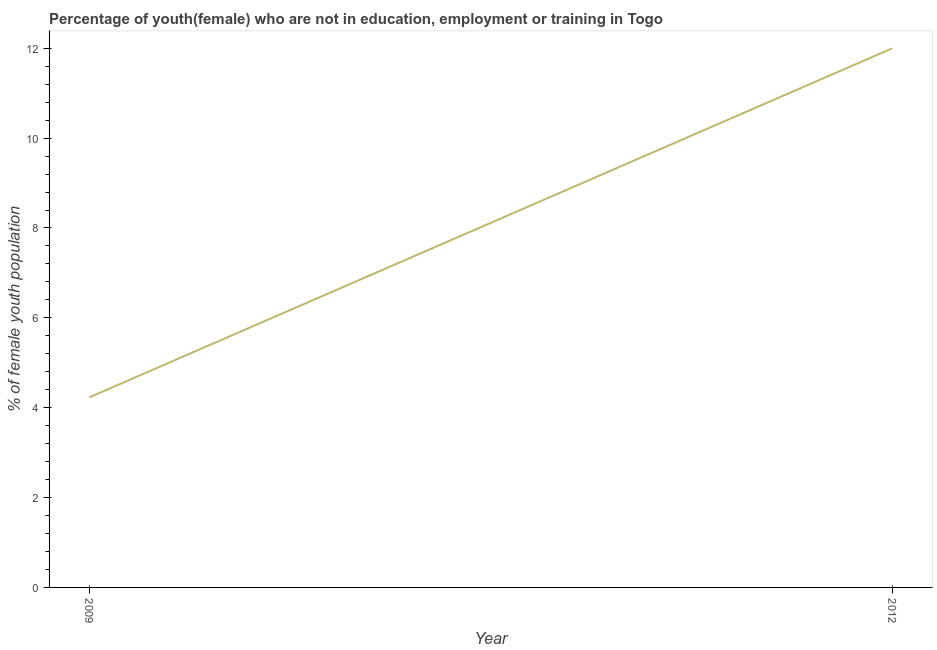Across all years, what is the minimum unemployed female youth population?
Ensure brevity in your answer.  4.23. In which year was the unemployed female youth population minimum?
Provide a short and direct response. 2009. What is the sum of the unemployed female youth population?
Your answer should be very brief. 16.23. What is the difference between the unemployed female youth population in 2009 and 2012?
Offer a terse response. -7.77. What is the average unemployed female youth population per year?
Give a very brief answer. 8.12. What is the median unemployed female youth population?
Make the answer very short. 8.12. In how many years, is the unemployed female youth population greater than 0.8 %?
Your answer should be very brief. 2. What is the ratio of the unemployed female youth population in 2009 to that in 2012?
Provide a short and direct response. 0.35. In how many years, is the unemployed female youth population greater than the average unemployed female youth population taken over all years?
Offer a very short reply. 1. How many years are there in the graph?
Your answer should be very brief. 2. What is the difference between two consecutive major ticks on the Y-axis?
Provide a succinct answer. 2. Does the graph contain any zero values?
Ensure brevity in your answer.  No. Does the graph contain grids?
Keep it short and to the point. No. What is the title of the graph?
Provide a short and direct response. Percentage of youth(female) who are not in education, employment or training in Togo. What is the label or title of the X-axis?
Make the answer very short. Year. What is the label or title of the Y-axis?
Your answer should be very brief. % of female youth population. What is the % of female youth population of 2009?
Provide a succinct answer. 4.23. What is the difference between the % of female youth population in 2009 and 2012?
Your answer should be compact. -7.77. What is the ratio of the % of female youth population in 2009 to that in 2012?
Provide a short and direct response. 0.35. 